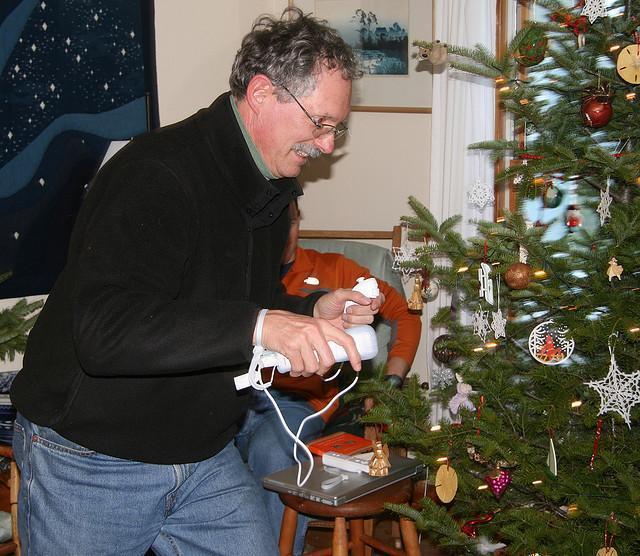How many people can be seen?
Give a very brief answer. 2. How many of these buses are big red tall boys with two floors nice??
Give a very brief answer. 0. 